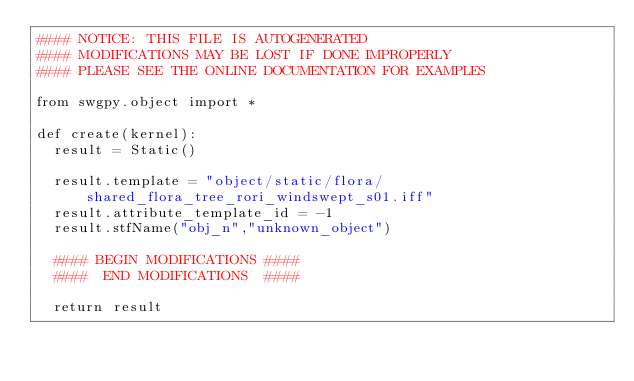<code> <loc_0><loc_0><loc_500><loc_500><_Python_>#### NOTICE: THIS FILE IS AUTOGENERATED
#### MODIFICATIONS MAY BE LOST IF DONE IMPROPERLY
#### PLEASE SEE THE ONLINE DOCUMENTATION FOR EXAMPLES

from swgpy.object import *	

def create(kernel):
	result = Static()

	result.template = "object/static/flora/shared_flora_tree_rori_windswept_s01.iff"
	result.attribute_template_id = -1
	result.stfName("obj_n","unknown_object")		
	
	#### BEGIN MODIFICATIONS ####
	####  END MODIFICATIONS  ####
	
	return result</code> 